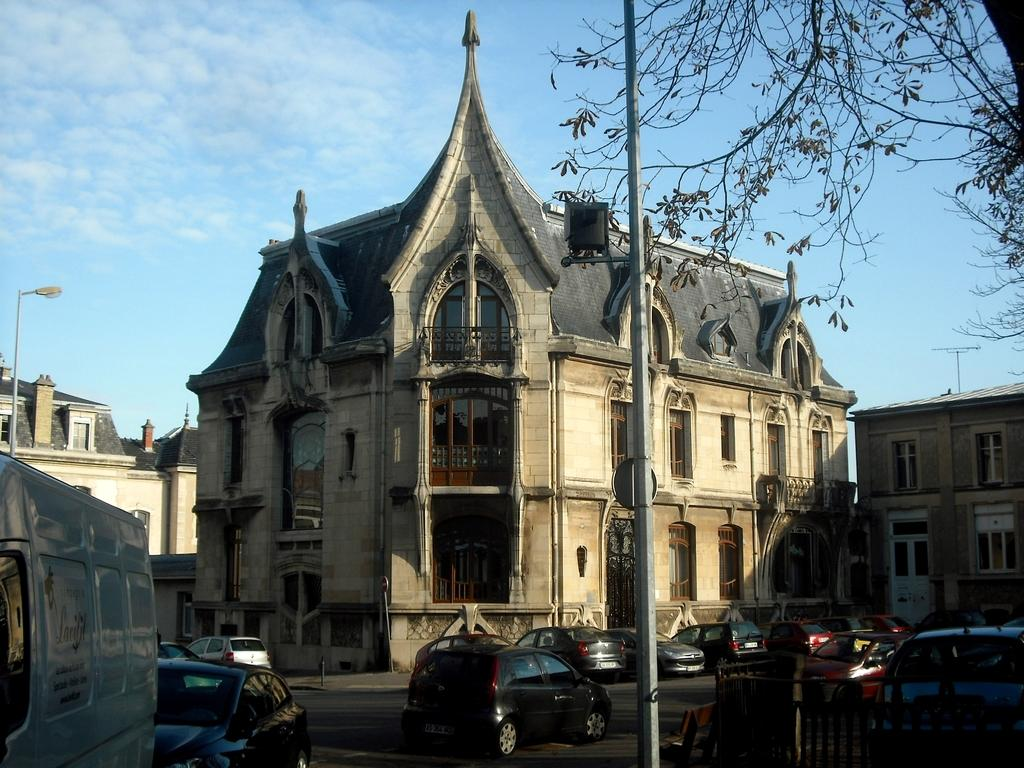What type of structures can be seen in the image? There are buildings with windows in the image. What is happening on the road in the image? There is a group of vehicles on the road. What are some other objects present in the image? There are poles, a tree, a fence, and a street pole in the image. What can be seen in the sky in the image? The sky is visible in the image. Which actor is performing on the street pole in the image? There is no actor performing on the street pole in the image; it is a stationary object. How does the image show respect for the environment? The image does not explicitly show respect for the environment; it is a visual representation of a scene with various objects and structures. 